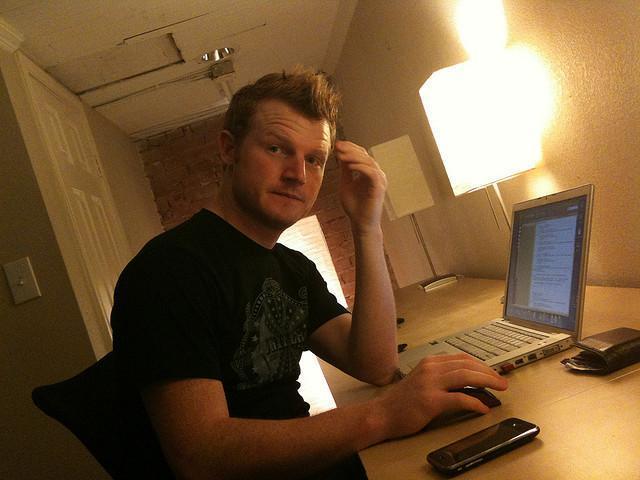How many lamps are in the picture?
Give a very brief answer. 2. 